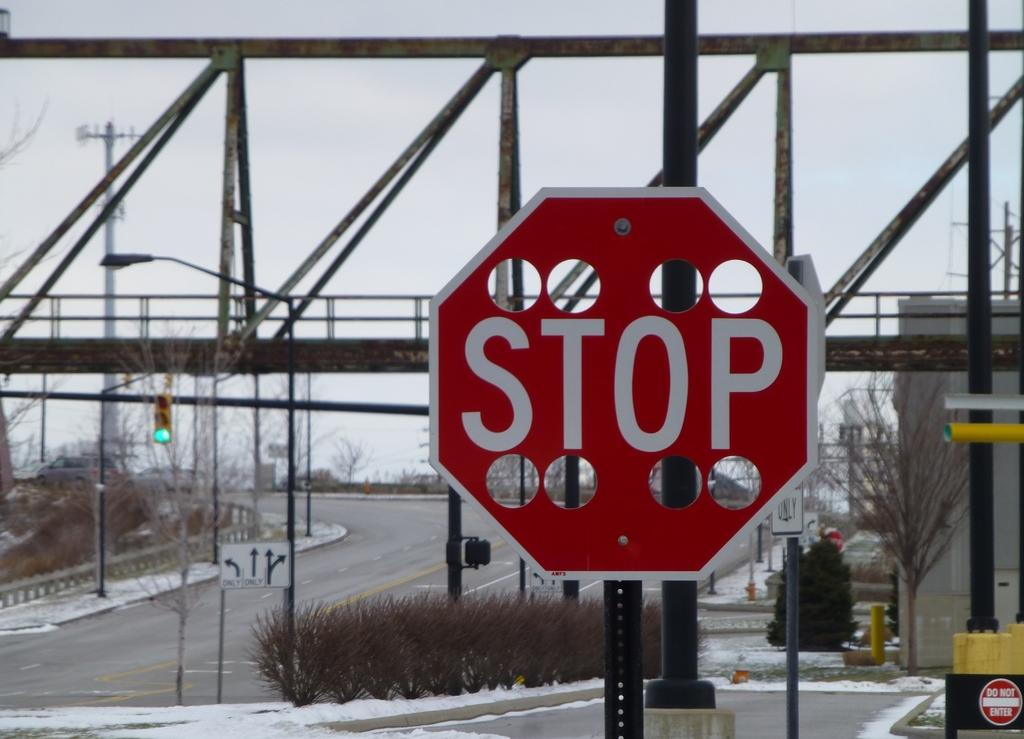What is located at the front of the image? There is a board with text in the front of the image. What can be seen in the center of the image? There is a bridge in the center of the image. What objects are present in the image that resemble long, thin structures? There are poles in the image. What type of vegetation is visible in the image? There are plants in the image. What can be seen in the background of the image? There are trees in the background of the image. What type of basket is hanging from the bridge in the image? There is no basket present in the image, and the bridge does not have any hanging objects. What is the answer to the question written on the board in the image? The image does not provide enough information to determine the answer to the question on the board. 